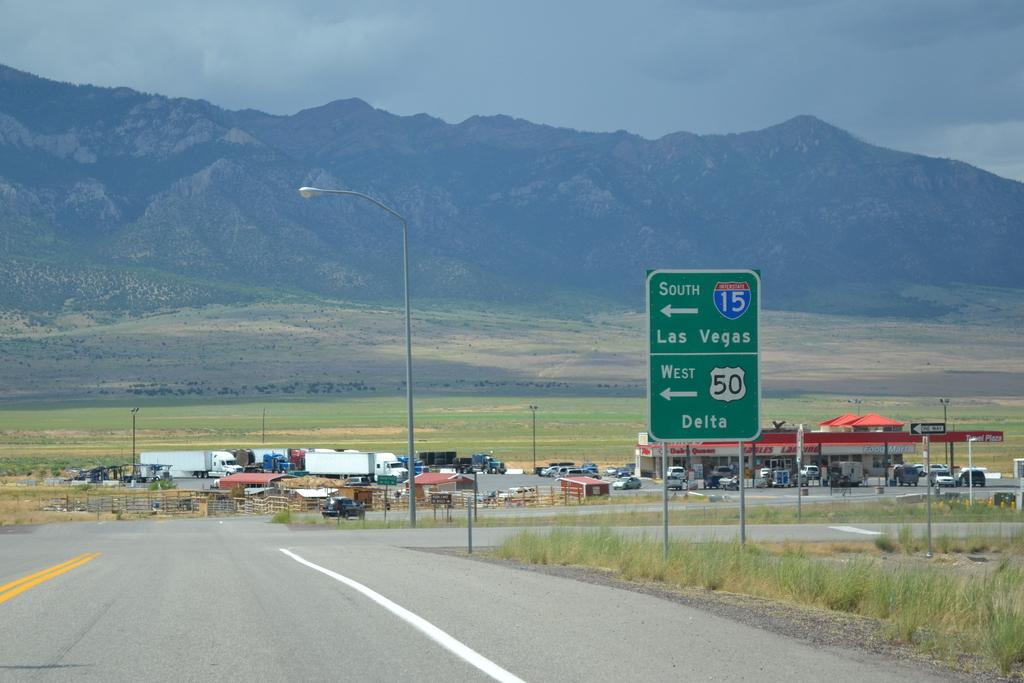Provide a one-sentence caption for the provided image. A shot on a highway interesection of interstate 15 south with a gas station in the distance. 